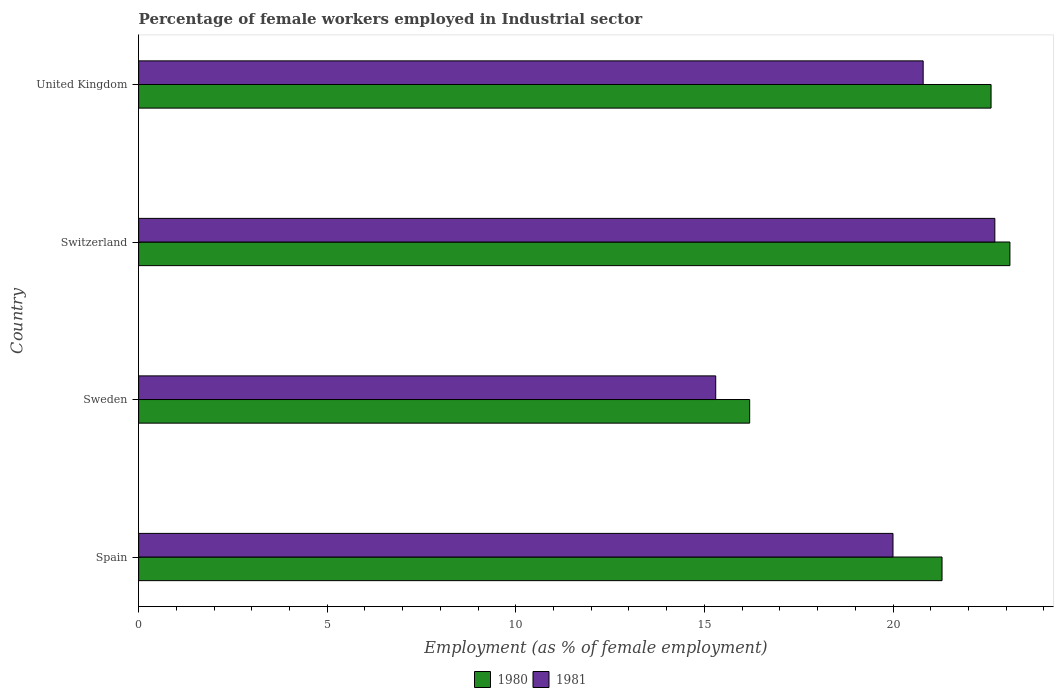How many different coloured bars are there?
Make the answer very short. 2. How many groups of bars are there?
Give a very brief answer. 4. How many bars are there on the 2nd tick from the top?
Your response must be concise. 2. What is the label of the 1st group of bars from the top?
Your response must be concise. United Kingdom. What is the percentage of females employed in Industrial sector in 1981 in Sweden?
Give a very brief answer. 15.3. Across all countries, what is the maximum percentage of females employed in Industrial sector in 1980?
Offer a very short reply. 23.1. Across all countries, what is the minimum percentage of females employed in Industrial sector in 1981?
Your answer should be very brief. 15.3. In which country was the percentage of females employed in Industrial sector in 1980 maximum?
Keep it short and to the point. Switzerland. What is the total percentage of females employed in Industrial sector in 1981 in the graph?
Your response must be concise. 78.8. What is the difference between the percentage of females employed in Industrial sector in 1980 in Spain and that in Switzerland?
Your answer should be very brief. -1.8. What is the difference between the percentage of females employed in Industrial sector in 1981 in United Kingdom and the percentage of females employed in Industrial sector in 1980 in Sweden?
Give a very brief answer. 4.6. What is the average percentage of females employed in Industrial sector in 1980 per country?
Offer a terse response. 20.8. What is the difference between the percentage of females employed in Industrial sector in 1981 and percentage of females employed in Industrial sector in 1980 in United Kingdom?
Your response must be concise. -1.8. In how many countries, is the percentage of females employed in Industrial sector in 1981 greater than 11 %?
Make the answer very short. 4. What is the ratio of the percentage of females employed in Industrial sector in 1980 in Spain to that in United Kingdom?
Your answer should be compact. 0.94. Is the percentage of females employed in Industrial sector in 1980 in Spain less than that in Sweden?
Offer a terse response. No. What is the difference between the highest and the second highest percentage of females employed in Industrial sector in 1980?
Your response must be concise. 0.5. What is the difference between the highest and the lowest percentage of females employed in Industrial sector in 1980?
Offer a terse response. 6.9. Is the sum of the percentage of females employed in Industrial sector in 1981 in Switzerland and United Kingdom greater than the maximum percentage of females employed in Industrial sector in 1980 across all countries?
Make the answer very short. Yes. What does the 2nd bar from the bottom in United Kingdom represents?
Your answer should be very brief. 1981. How many bars are there?
Offer a terse response. 8. How many countries are there in the graph?
Your response must be concise. 4. What is the difference between two consecutive major ticks on the X-axis?
Provide a short and direct response. 5. Does the graph contain any zero values?
Your answer should be compact. No. What is the title of the graph?
Keep it short and to the point. Percentage of female workers employed in Industrial sector. Does "1961" appear as one of the legend labels in the graph?
Ensure brevity in your answer.  No. What is the label or title of the X-axis?
Provide a succinct answer. Employment (as % of female employment). What is the label or title of the Y-axis?
Offer a terse response. Country. What is the Employment (as % of female employment) in 1980 in Spain?
Make the answer very short. 21.3. What is the Employment (as % of female employment) of 1981 in Spain?
Offer a terse response. 20. What is the Employment (as % of female employment) in 1980 in Sweden?
Offer a terse response. 16.2. What is the Employment (as % of female employment) of 1981 in Sweden?
Offer a terse response. 15.3. What is the Employment (as % of female employment) in 1980 in Switzerland?
Give a very brief answer. 23.1. What is the Employment (as % of female employment) of 1981 in Switzerland?
Your answer should be compact. 22.7. What is the Employment (as % of female employment) of 1980 in United Kingdom?
Keep it short and to the point. 22.6. What is the Employment (as % of female employment) of 1981 in United Kingdom?
Your answer should be compact. 20.8. Across all countries, what is the maximum Employment (as % of female employment) of 1980?
Ensure brevity in your answer.  23.1. Across all countries, what is the maximum Employment (as % of female employment) of 1981?
Provide a succinct answer. 22.7. Across all countries, what is the minimum Employment (as % of female employment) in 1980?
Make the answer very short. 16.2. Across all countries, what is the minimum Employment (as % of female employment) in 1981?
Keep it short and to the point. 15.3. What is the total Employment (as % of female employment) in 1980 in the graph?
Ensure brevity in your answer.  83.2. What is the total Employment (as % of female employment) in 1981 in the graph?
Offer a terse response. 78.8. What is the difference between the Employment (as % of female employment) of 1980 in Spain and that in Sweden?
Your response must be concise. 5.1. What is the difference between the Employment (as % of female employment) in 1981 in Spain and that in Sweden?
Your response must be concise. 4.7. What is the difference between the Employment (as % of female employment) of 1981 in Spain and that in Switzerland?
Ensure brevity in your answer.  -2.7. What is the difference between the Employment (as % of female employment) of 1980 in Sweden and that in Switzerland?
Your response must be concise. -6.9. What is the difference between the Employment (as % of female employment) of 1981 in Sweden and that in United Kingdom?
Give a very brief answer. -5.5. What is the difference between the Employment (as % of female employment) of 1981 in Switzerland and that in United Kingdom?
Make the answer very short. 1.9. What is the difference between the Employment (as % of female employment) in 1980 in Sweden and the Employment (as % of female employment) in 1981 in Switzerland?
Keep it short and to the point. -6.5. What is the average Employment (as % of female employment) of 1980 per country?
Your answer should be compact. 20.8. What is the average Employment (as % of female employment) in 1981 per country?
Provide a succinct answer. 19.7. What is the difference between the Employment (as % of female employment) of 1980 and Employment (as % of female employment) of 1981 in Sweden?
Make the answer very short. 0.9. What is the ratio of the Employment (as % of female employment) in 1980 in Spain to that in Sweden?
Offer a terse response. 1.31. What is the ratio of the Employment (as % of female employment) in 1981 in Spain to that in Sweden?
Ensure brevity in your answer.  1.31. What is the ratio of the Employment (as % of female employment) in 1980 in Spain to that in Switzerland?
Offer a very short reply. 0.92. What is the ratio of the Employment (as % of female employment) in 1981 in Spain to that in Switzerland?
Give a very brief answer. 0.88. What is the ratio of the Employment (as % of female employment) of 1980 in Spain to that in United Kingdom?
Your answer should be compact. 0.94. What is the ratio of the Employment (as % of female employment) in 1981 in Spain to that in United Kingdom?
Your answer should be very brief. 0.96. What is the ratio of the Employment (as % of female employment) in 1980 in Sweden to that in Switzerland?
Your answer should be compact. 0.7. What is the ratio of the Employment (as % of female employment) of 1981 in Sweden to that in Switzerland?
Ensure brevity in your answer.  0.67. What is the ratio of the Employment (as % of female employment) of 1980 in Sweden to that in United Kingdom?
Your answer should be very brief. 0.72. What is the ratio of the Employment (as % of female employment) of 1981 in Sweden to that in United Kingdom?
Make the answer very short. 0.74. What is the ratio of the Employment (as % of female employment) of 1980 in Switzerland to that in United Kingdom?
Your answer should be compact. 1.02. What is the ratio of the Employment (as % of female employment) of 1981 in Switzerland to that in United Kingdom?
Your answer should be compact. 1.09. What is the difference between the highest and the second highest Employment (as % of female employment) in 1980?
Your response must be concise. 0.5. What is the difference between the highest and the second highest Employment (as % of female employment) in 1981?
Offer a very short reply. 1.9. What is the difference between the highest and the lowest Employment (as % of female employment) in 1981?
Keep it short and to the point. 7.4. 